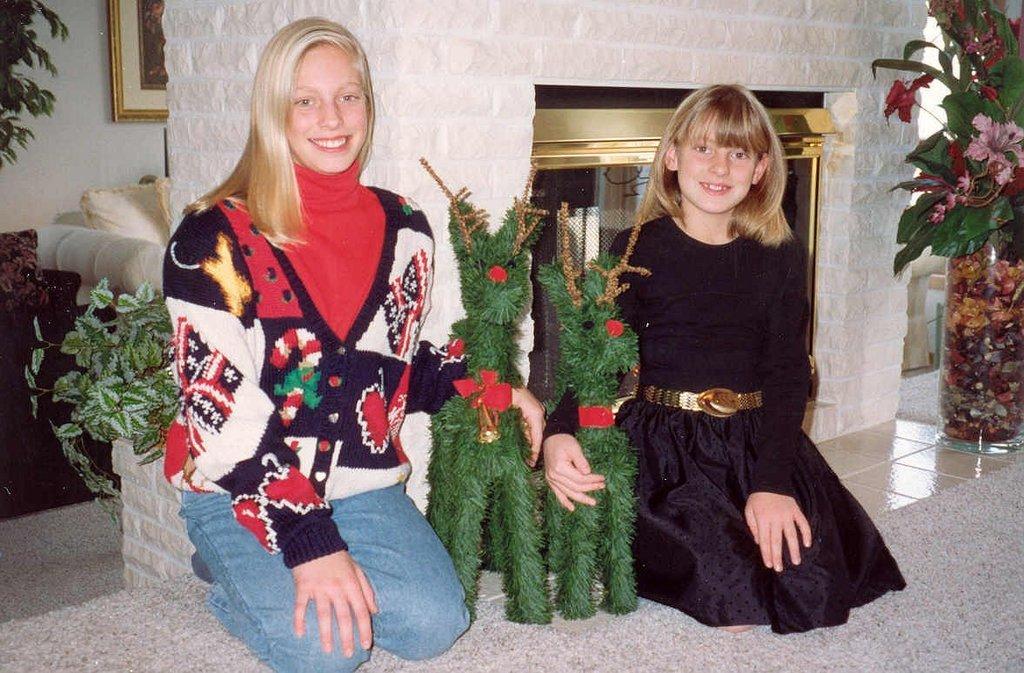Could you give a brief overview of what you see in this image? On the left side, there is a girl in red color t-shirt, kneeling down, smiling and holding a green color doll with a hand. On the right side, there is another girl in black in black color dress, kneeling down on the floor and there is a flower vase. In the background, there are plants, photo frame attached to the white wall and there are other objects. 